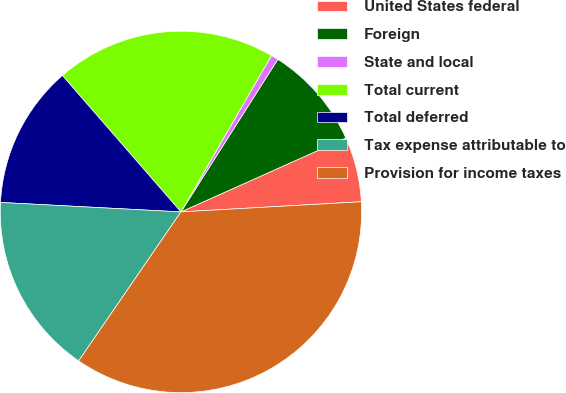Convert chart. <chart><loc_0><loc_0><loc_500><loc_500><pie_chart><fcel>United States federal<fcel>Foreign<fcel>State and local<fcel>Total current<fcel>Total deferred<fcel>Tax expense attributable to<fcel>Provision for income taxes<nl><fcel>5.81%<fcel>9.29%<fcel>0.65%<fcel>19.74%<fcel>12.78%<fcel>16.26%<fcel>35.47%<nl></chart> 